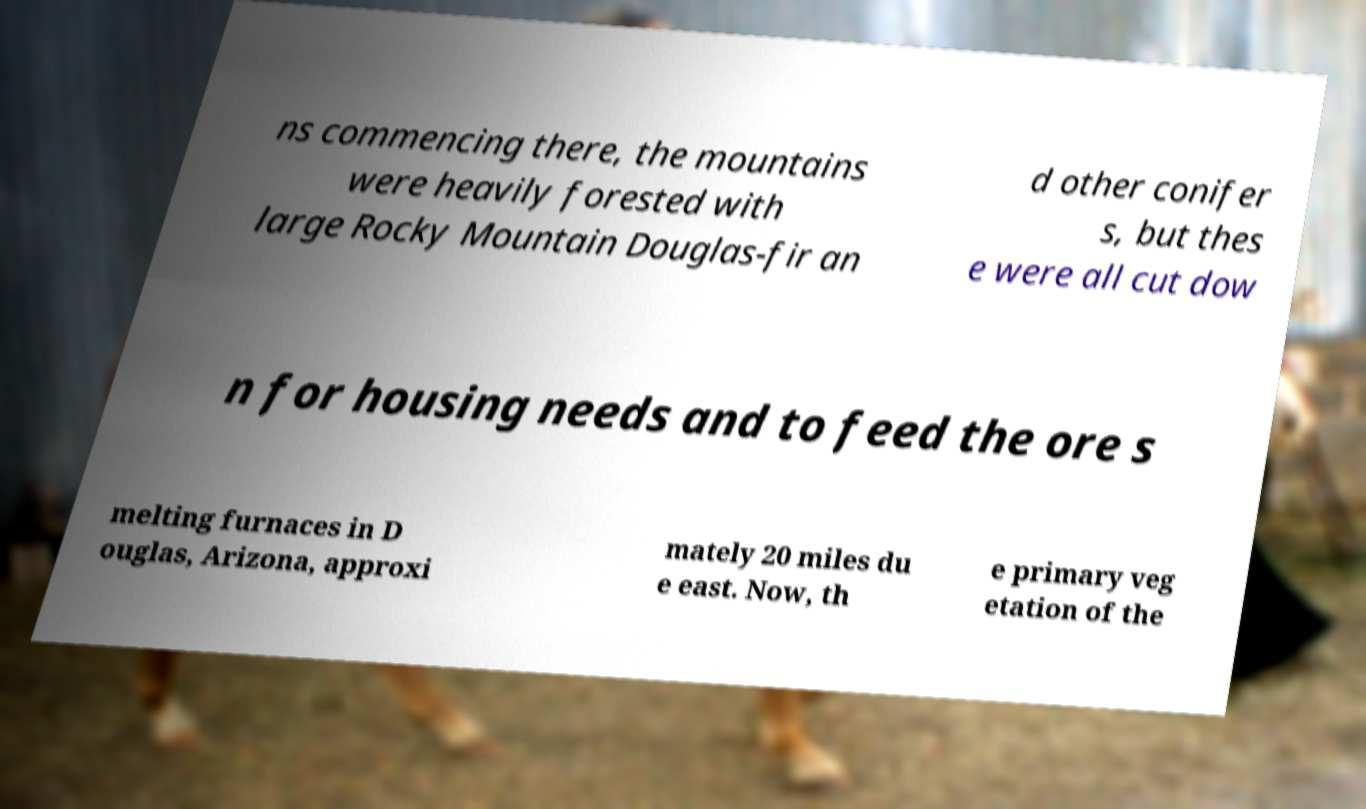Could you extract and type out the text from this image? ns commencing there, the mountains were heavily forested with large Rocky Mountain Douglas-fir an d other conifer s, but thes e were all cut dow n for housing needs and to feed the ore s melting furnaces in D ouglas, Arizona, approxi mately 20 miles du e east. Now, th e primary veg etation of the 